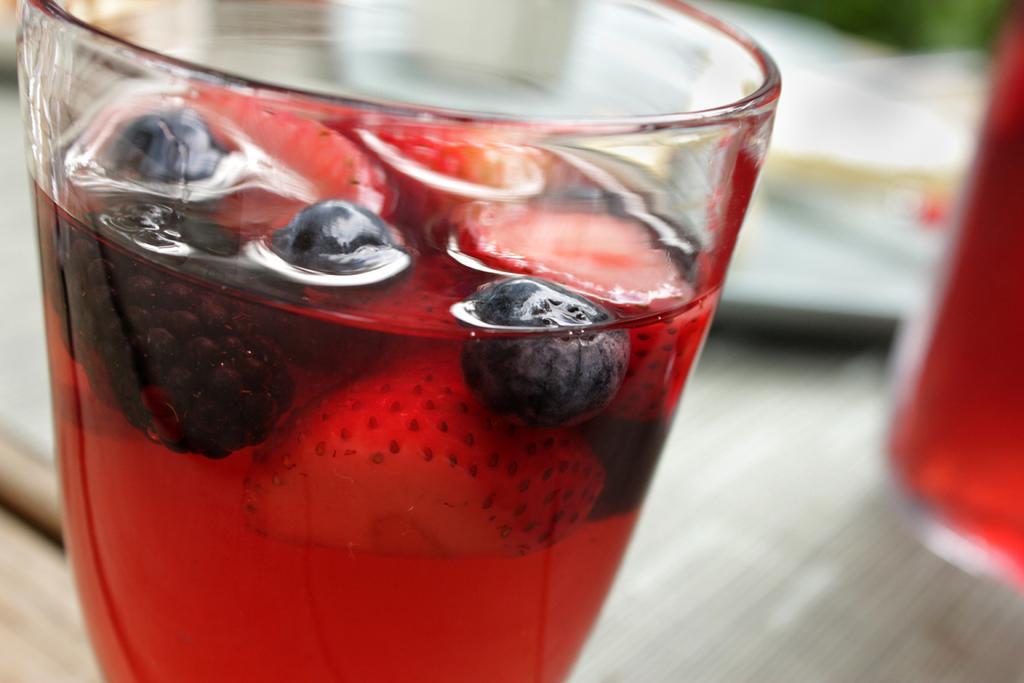Please provide a concise description of this image. In this image we can see a glass on the surface containing some liquid, pieces of strawberries, raspberries and blueberries in it. We can also see a glass and a plate beside it. 